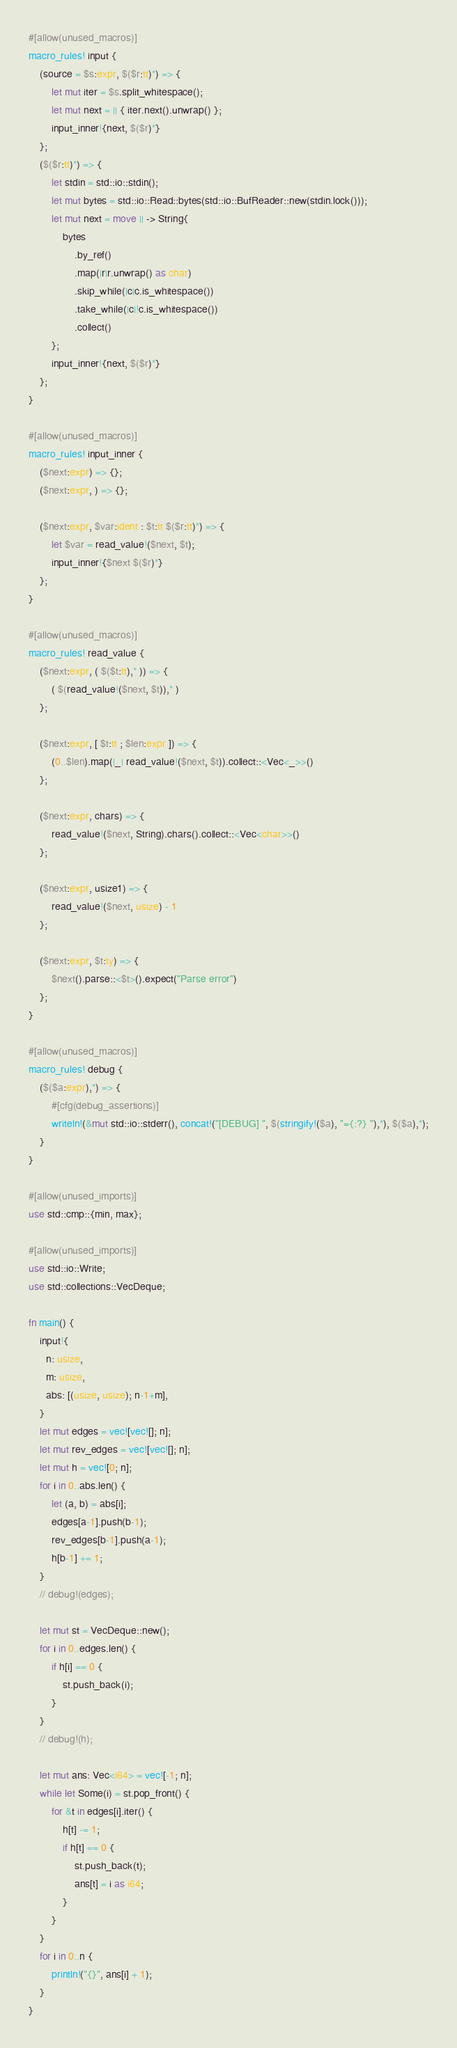Convert code to text. <code><loc_0><loc_0><loc_500><loc_500><_Rust_>#[allow(unused_macros)]
macro_rules! input {
    (source = $s:expr, $($r:tt)*) => {
        let mut iter = $s.split_whitespace();
        let mut next = || { iter.next().unwrap() };
        input_inner!{next, $($r)*}
    };
    ($($r:tt)*) => {
        let stdin = std::io::stdin();
        let mut bytes = std::io::Read::bytes(std::io::BufReader::new(stdin.lock()));
        let mut next = move || -> String{
            bytes
                .by_ref()
                .map(|r|r.unwrap() as char)
                .skip_while(|c|c.is_whitespace())
                .take_while(|c|!c.is_whitespace())
                .collect()
        };
        input_inner!{next, $($r)*}
    };
}

#[allow(unused_macros)]
macro_rules! input_inner {
    ($next:expr) => {};
    ($next:expr, ) => {};

    ($next:expr, $var:ident : $t:tt $($r:tt)*) => {
        let $var = read_value!($next, $t);
        input_inner!{$next $($r)*}
    };
}

#[allow(unused_macros)]
macro_rules! read_value {
    ($next:expr, ( $($t:tt),* )) => {
        ( $(read_value!($next, $t)),* )
    };

    ($next:expr, [ $t:tt ; $len:expr ]) => {
        (0..$len).map(|_| read_value!($next, $t)).collect::<Vec<_>>()
    };

    ($next:expr, chars) => {
        read_value!($next, String).chars().collect::<Vec<char>>()
    };

    ($next:expr, usize1) => {
        read_value!($next, usize) - 1
    };

    ($next:expr, $t:ty) => {
        $next().parse::<$t>().expect("Parse error")
    };
}

#[allow(unused_macros)]
macro_rules! debug {
    ($($a:expr),*) => {
        #[cfg(debug_assertions)]
        writeln!(&mut std::io::stderr(), concat!("[DEBUG] ", $(stringify!($a), "={:?} "),*), $($a),*);
    }
}

#[allow(unused_imports)]
use std::cmp::{min, max};

#[allow(unused_imports)]
use std::io::Write;
use std::collections::VecDeque;

fn main() {
    input!{
      n: usize,
      m: usize,
      abs: [(usize, usize); n-1+m],
    }
    let mut edges = vec![vec![]; n];
    let mut rev_edges = vec![vec![]; n];
    let mut h = vec![0; n];
    for i in 0..abs.len() {
        let (a, b) = abs[i];
        edges[a-1].push(b-1);
        rev_edges[b-1].push(a-1);
        h[b-1] += 1;
    }
    // debug!(edges);

    let mut st = VecDeque::new();
    for i in 0..edges.len() {
        if h[i] == 0 {
            st.push_back(i);
        }
    }
    // debug!(h);

    let mut ans: Vec<i64> = vec![-1; n];
    while let Some(i) = st.pop_front() {
        for &t in edges[i].iter() {
            h[t] -= 1;
            if h[t] == 0 {
                st.push_back(t);
                ans[t] = i as i64;
            }
        }
    }
    for i in 0..n {
        println!("{}", ans[i] + 1);
    }
}
</code> 